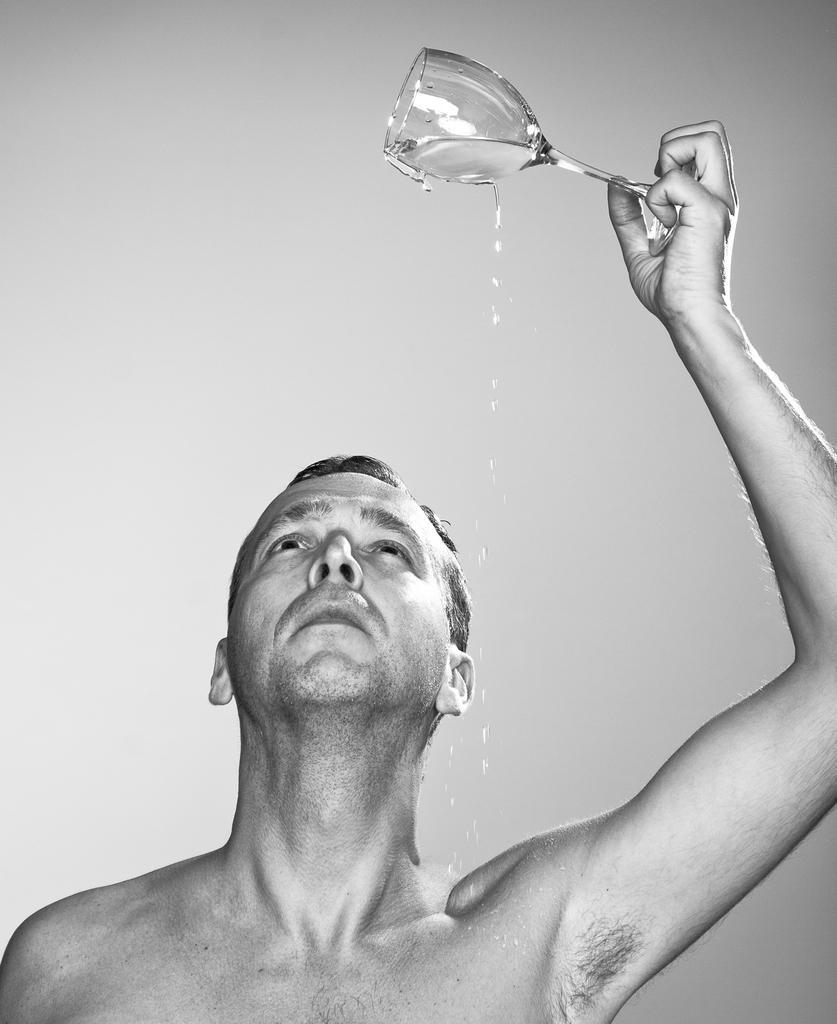How would you summarize this image in a sentence or two? A man pouring water from glass on him. 